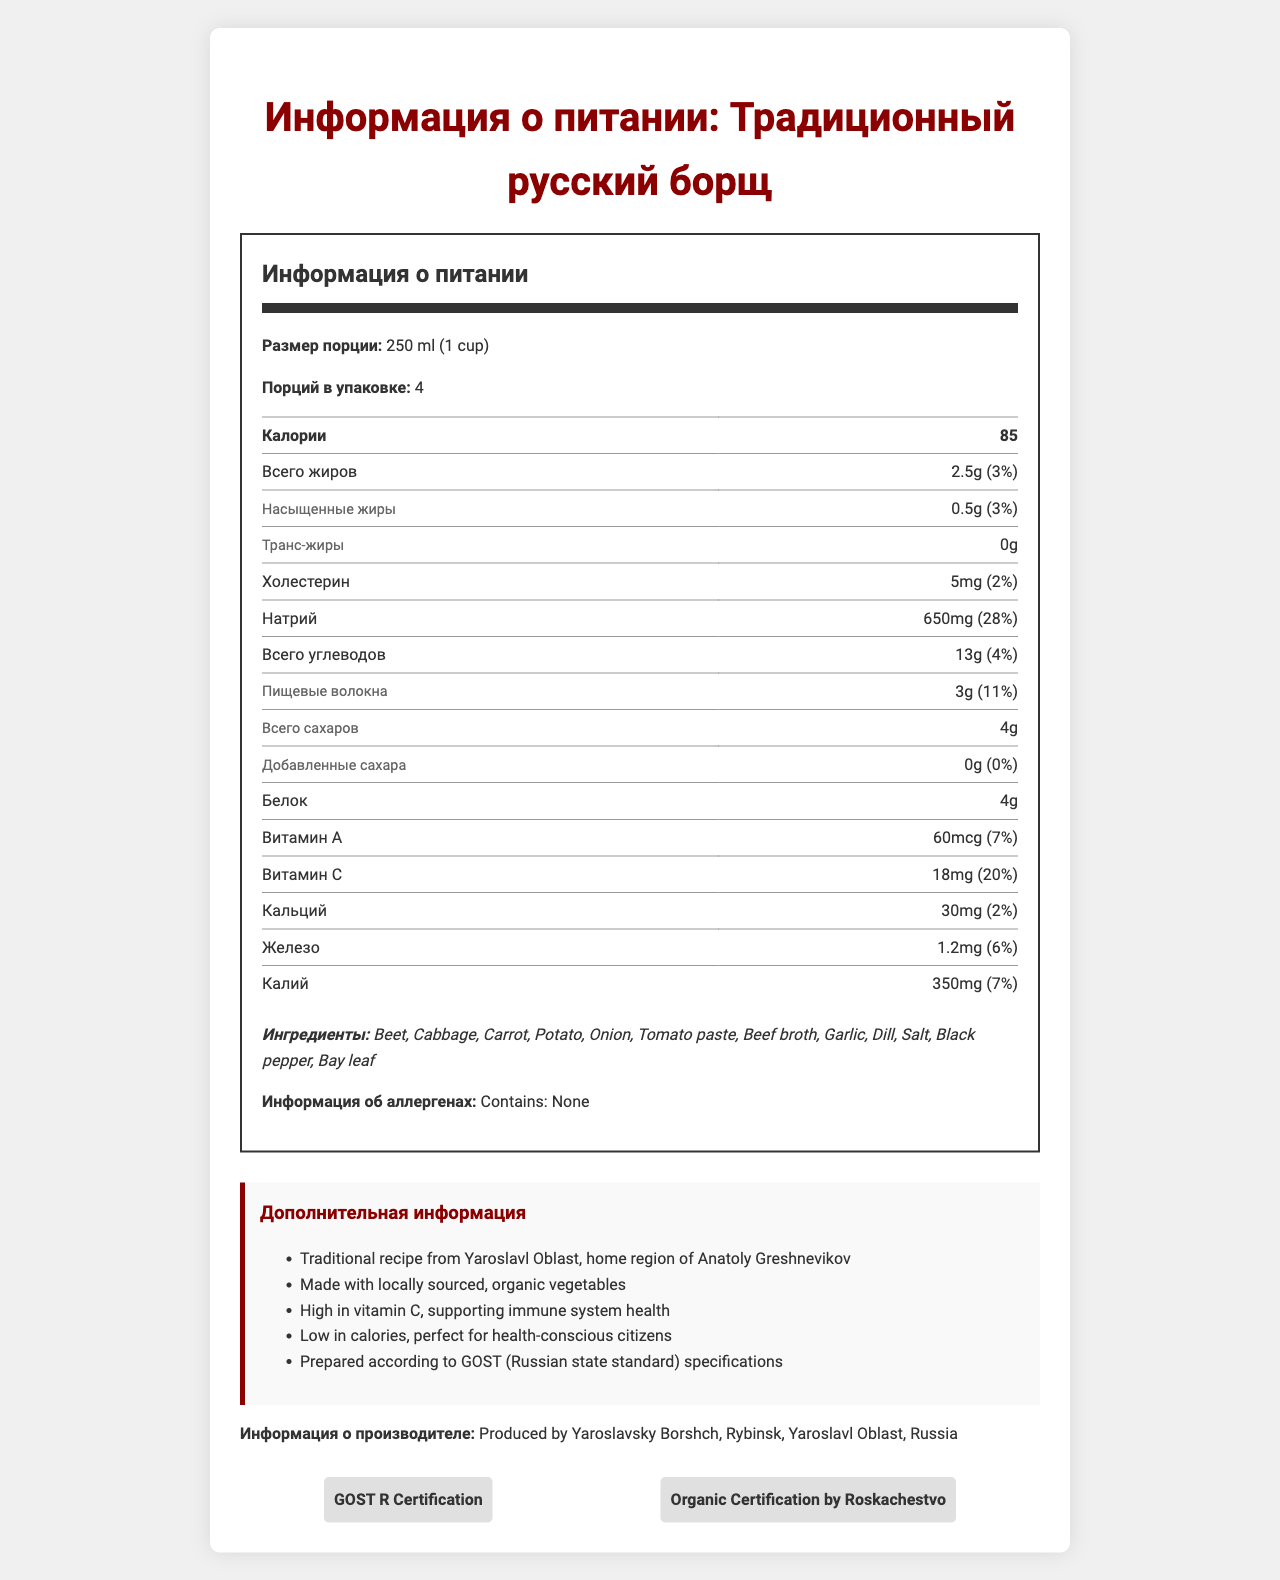who is the manufacturer of this borscht? The document states that the manufacturer is "Yaroslavsky Borshch, Rybinsk, Yaroslavl Oblast, Russia" in the manufacturer information section.
Answer: Yaroslavsky Borshch, Rybinsk, Yaroslavl Oblast, Russia how many calories are in one serving? The document shows that each serving of borscht contains 85 calories.
Answer: 85 what is the main source of Vitamin C in this borscht? The document states that one serving of borscht contains 18mg of Vitamin C, which is 20% of the Daily Value.
Answer: Traditional Russian Borscht contains 18mg (20% of Daily Value). how much sodium does one serving contain? According to the nutrition facts, one serving contains 650mg of sodium, which is 28% of the Daily Value.
Answer: 650mg how much dietary fiber is in one serving? The nutrition facts label indicates that one serving of borscht contains 3g of dietary fiber, which is 11% of the Daily Value.
Answer: 3g what is the percentage of the daily value for vitamin C provided by one serving? A. 10% B. 15% C. 20% The document states that one serving of borscht provides 20% of the Daily Value for Vitamin C.
Answer: C which ingredient is NOT in the borscht recipe? A. Beet B. Cabbage C. Potato D. Celery The list of ingredients includes Beet, Cabbage, and Potato, but not Celery.
Answer: D does the borscht contain any added sugars? The document states that the amount of added sugars is 0g, so there are no added sugars in the borscht.
Answer: No does this borscht adhere to any certifications? The borscht has GOST R Certification and Organic Certification by Roskachestvo as stated in the certifications section.
Answer: Yes summarize the entire document. The document offers a comprehensive overview of the nutritional profile, ingredients, and certifications of traditional Russian borscht, produced according to recognized standards.
Answer: The document provides nutritional information about traditional Russian borscht, including details like serving size, calories, various nutrients, and ingredients. It highlights that the borscht is high in Vitamin C, made with locally sourced organic vegetables, and follows GOST specifications. It also identifies the manufacturer and mentions relevant certifications. what are the health benefits mentioned for this borscht? The additional information section states the health benefits as high in Vitamin C, which supports immune system health, and low in calories, making it suitable for health-conscious citizens.
Answer: Supporting immune system health due to high vitamin C and being low in calories for health-conscious citizens. can this document provide the recipe for the borscht? The document lists the ingredients but does not provide the method or proportions needed to prepare the borscht.
Answer: Cannot be determined 